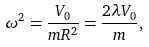<formula> <loc_0><loc_0><loc_500><loc_500>\omega ^ { 2 } = \frac { V _ { 0 } } { m R ^ { 2 } } = \frac { 2 \lambda V _ { 0 } } { m } ,</formula> 